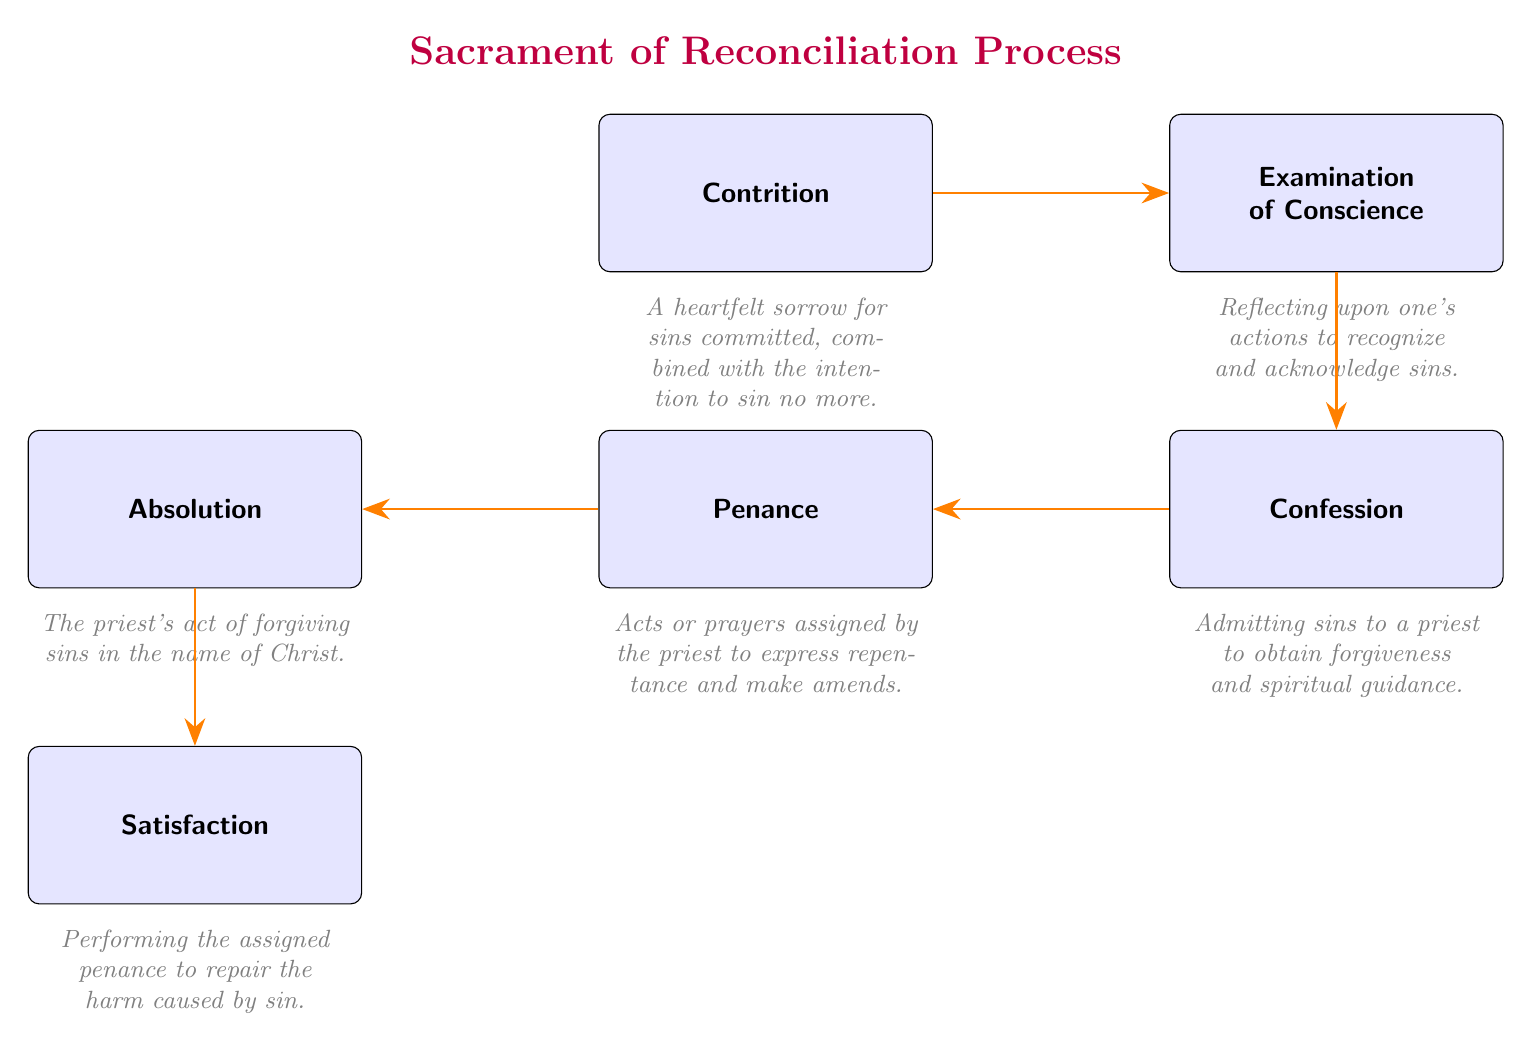What is the first step in the sacrament of reconciliation? The diagram indicates that the first step is "Contrition," which is the starting point of the process.
Answer: Contrition How many main steps are in the sacrament process? By counting each of the boxes in the flowchart, we see there are six main steps listed.
Answer: 6 What follows after confession in the flowchart? According to the flow of the diagram, the step that occurs after "Confession" is "Penance."
Answer: Penance What is the significance of absolution? The diagram states that "Absolution" is significant as it is described as the priest's act of forgiving sins in the name of Christ.
Answer: The priest's act of forgiving sins What is the last step in the sacrament process? Looking at the flow of the diagram, the last step is indicated as "Satisfaction."
Answer: Satisfaction How is the penance described in the diagram? The annotation for "Penance" describes it as acts or prayers assigned by the priest to express repentance.
Answer: Acts or prayers assigned by the priest What is the relationship between contrition and the examination of conscience? The diagram shows a directed flow arrow from "Contrition" to "Examination of Conscience," indicating that contrition leads to the next step.
Answer: Contrition leads to the examination What key intention is associated with contrition in the flowchart? The annotation under "Contrition" specifies that it includes the intention to sin no more, highlighting a critical aspect.
Answer: Intention to sin no more What is indicated as the purpose of satisfaction in the sacrament? The diagram indicates that "Satisfaction" is to perform the assigned penance to repair the harm caused by sin.
Answer: Repair the harm caused by sin 